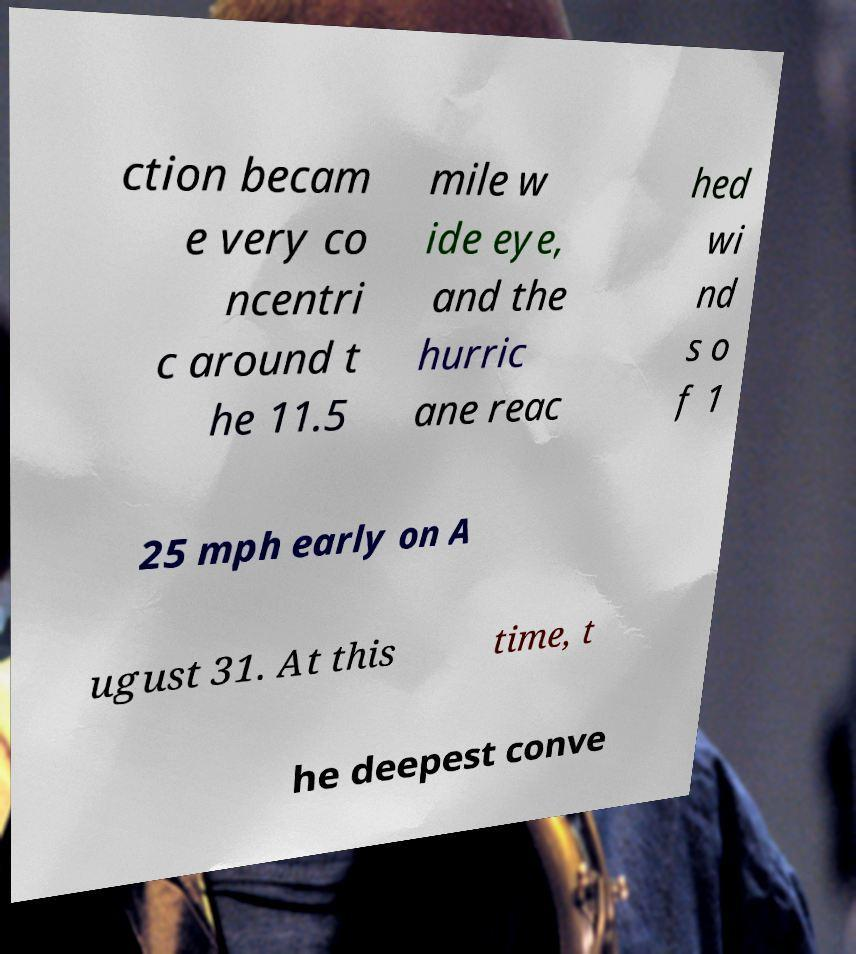Please identify and transcribe the text found in this image. ction becam e very co ncentri c around t he 11.5 mile w ide eye, and the hurric ane reac hed wi nd s o f 1 25 mph early on A ugust 31. At this time, t he deepest conve 